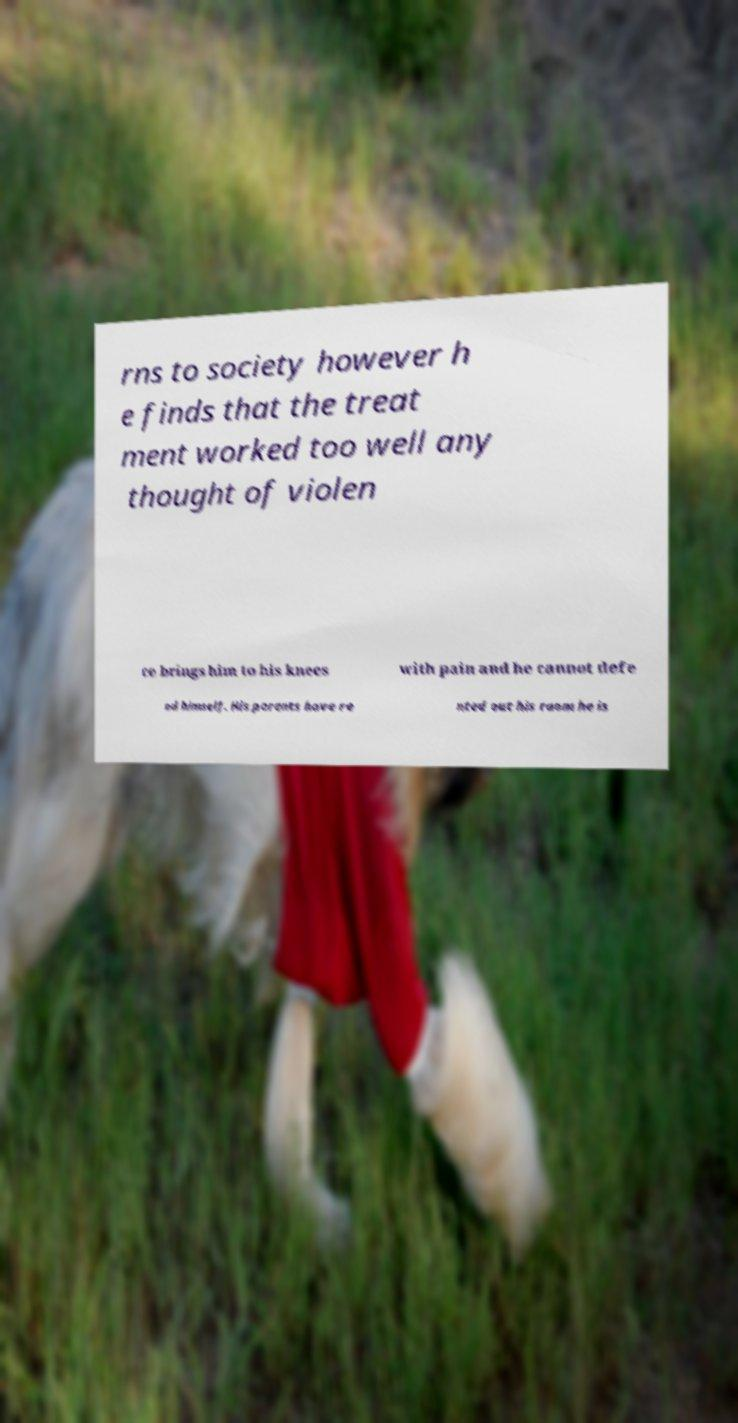I need the written content from this picture converted into text. Can you do that? rns to society however h e finds that the treat ment worked too well any thought of violen ce brings him to his knees with pain and he cannot defe nd himself. His parents have re nted out his room he is 